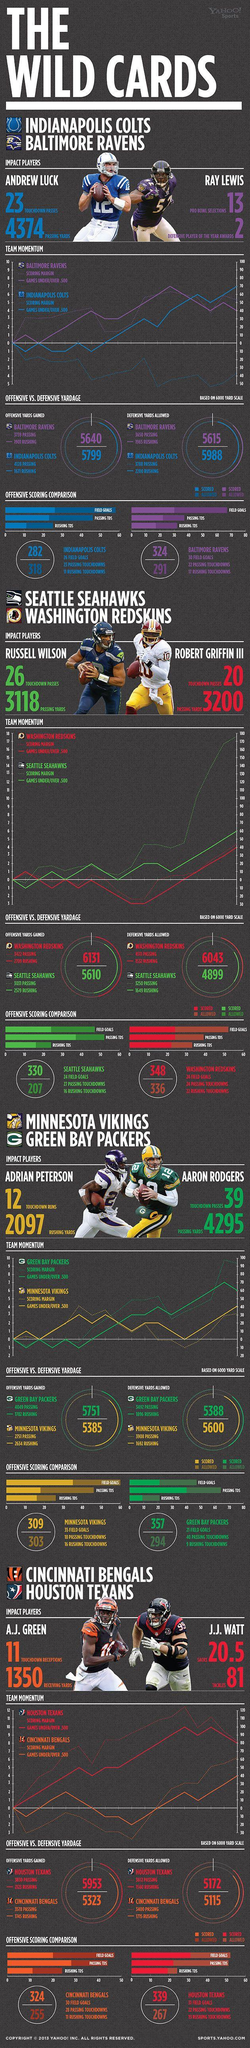Identify some key points in this picture. The field goal total for the Baltimore Ravens is 30. I have determined that the Passing Yards of Robert Griffin is 3200. The number of passing touchdowns by the Baltimore Ravens is 22. Robert Griffin III is a member of the Washington Redskins football team. The color code assigned to the Seattle Seahawks is green. 